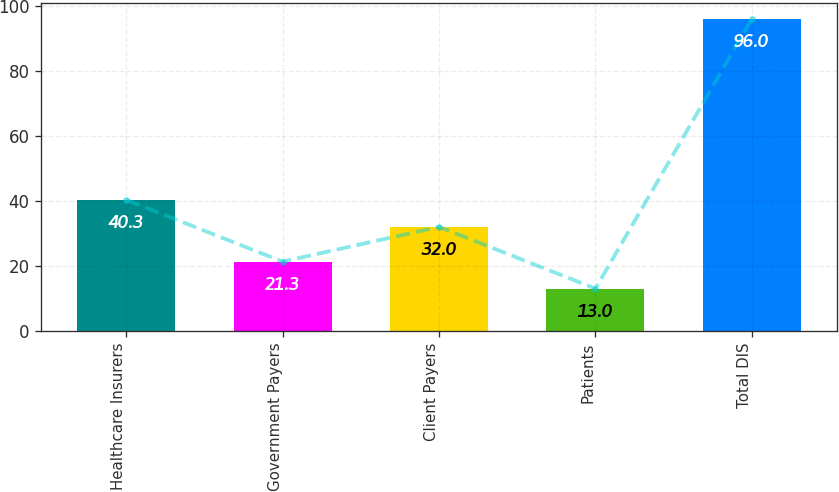Convert chart. <chart><loc_0><loc_0><loc_500><loc_500><bar_chart><fcel>Healthcare Insurers<fcel>Government Payers<fcel>Client Payers<fcel>Patients<fcel>Total DIS<nl><fcel>40.3<fcel>21.3<fcel>32<fcel>13<fcel>96<nl></chart> 